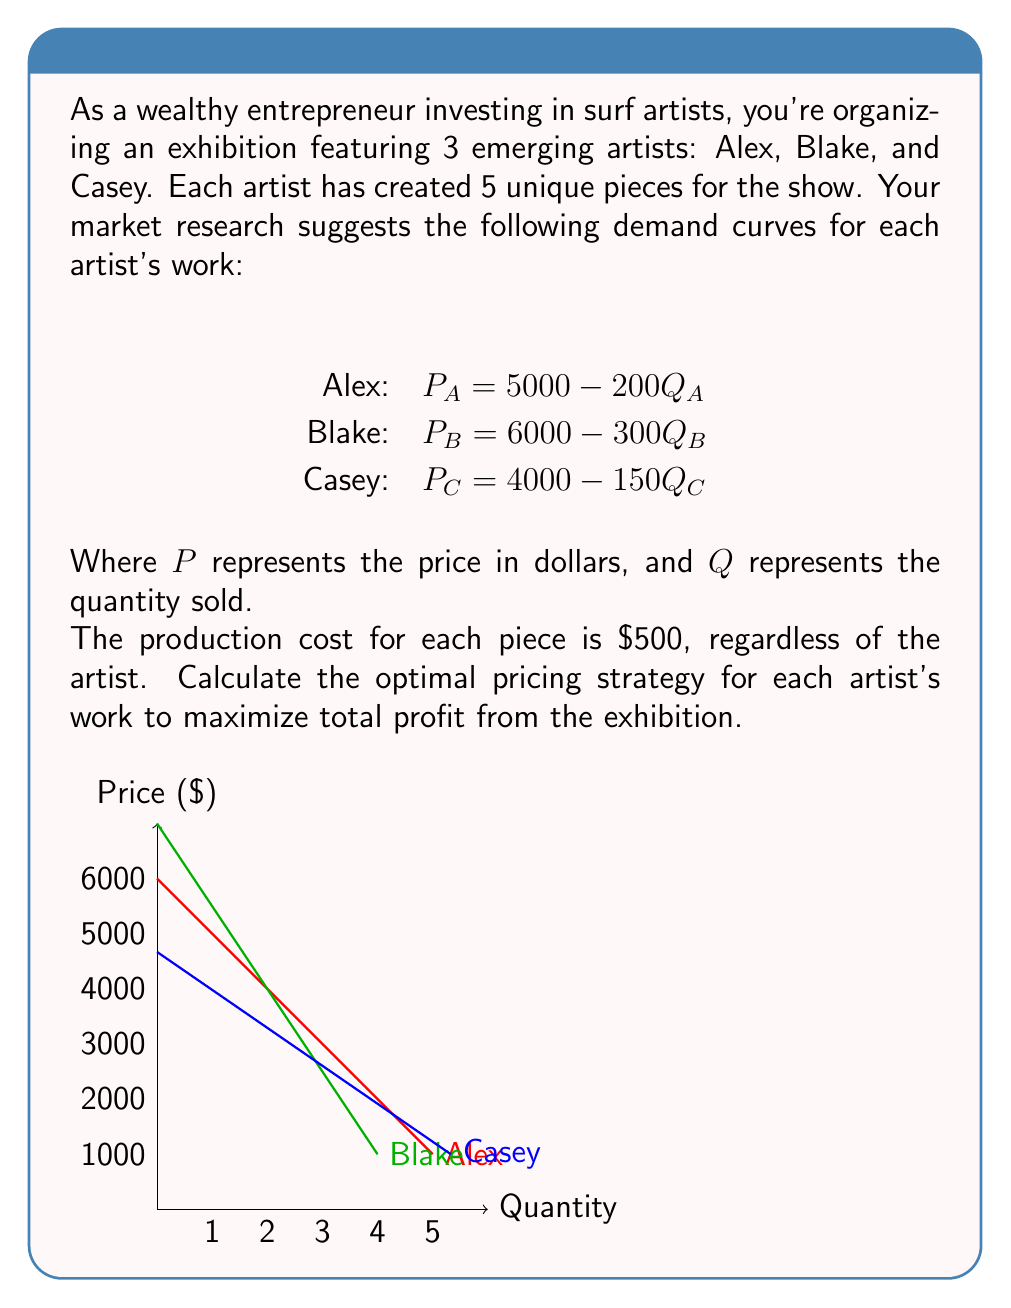Could you help me with this problem? To solve this problem, we'll follow these steps for each artist:

1. Express the total revenue (TR) function
2. Express the total cost (TC) function
3. Calculate the profit function (π = TR - TC)
4. Find the quantity that maximizes profit by setting dπ/dQ = 0
5. Calculate the optimal price using the demand curve equation

For Alex:
1. $TR_A = P_A \cdot Q_A = (5000 - 200Q_A) \cdot Q_A = 5000Q_A - 200Q_A^2$
2. $TC_A = 500Q_A$
3. $\pi_A = TR_A - TC_A = 5000Q_A - 200Q_A^2 - 500Q_A = 4500Q_A - 200Q_A^2$
4. $\frac{d\pi_A}{dQ_A} = 4500 - 400Q_A = 0$
   $400Q_A = 4500$
   $Q_A = 11.25$
   Since we can only sell whole pieces, we round down to 11.
5. $P_A = 5000 - 200(11) = 2800$

For Blake:
1. $TR_B = (6000 - 300Q_B) \cdot Q_B = 6000Q_B - 300Q_B^2$
2. $TC_B = 500Q_B$
3. $\pi_B = 5500Q_B - 300Q_B^2$
4. $\frac{d\pi_B}{dQ_B} = 5500 - 600Q_B = 0$
   $Q_B = 9.17$ (rounded down to 9)
5. $P_B = 6000 - 300(9) = 3300$

For Casey:
1. $TR_C = (4000 - 150Q_C) \cdot Q_C = 4000Q_C - 150Q_C^2$
2. $TC_C = 500Q_C$
3. $\pi_C = 3500Q_C - 150Q_C^2$
4. $\frac{d\pi_C}{dQ_C} = 3500 - 300Q_C = 0$
   $Q_C = 11.67$ (rounded down to 11)
5. $P_C = 4000 - 150(11) = 2350$

The optimal pricing strategy maximizes profit while staying within the constraint of 5 pieces per artist. Therefore, we'll price all 5 pieces from each artist at their respective optimal prices.
Answer: Alex: $2800 per piece, Blake: $3300 per piece, Casey: $2350 per piece 